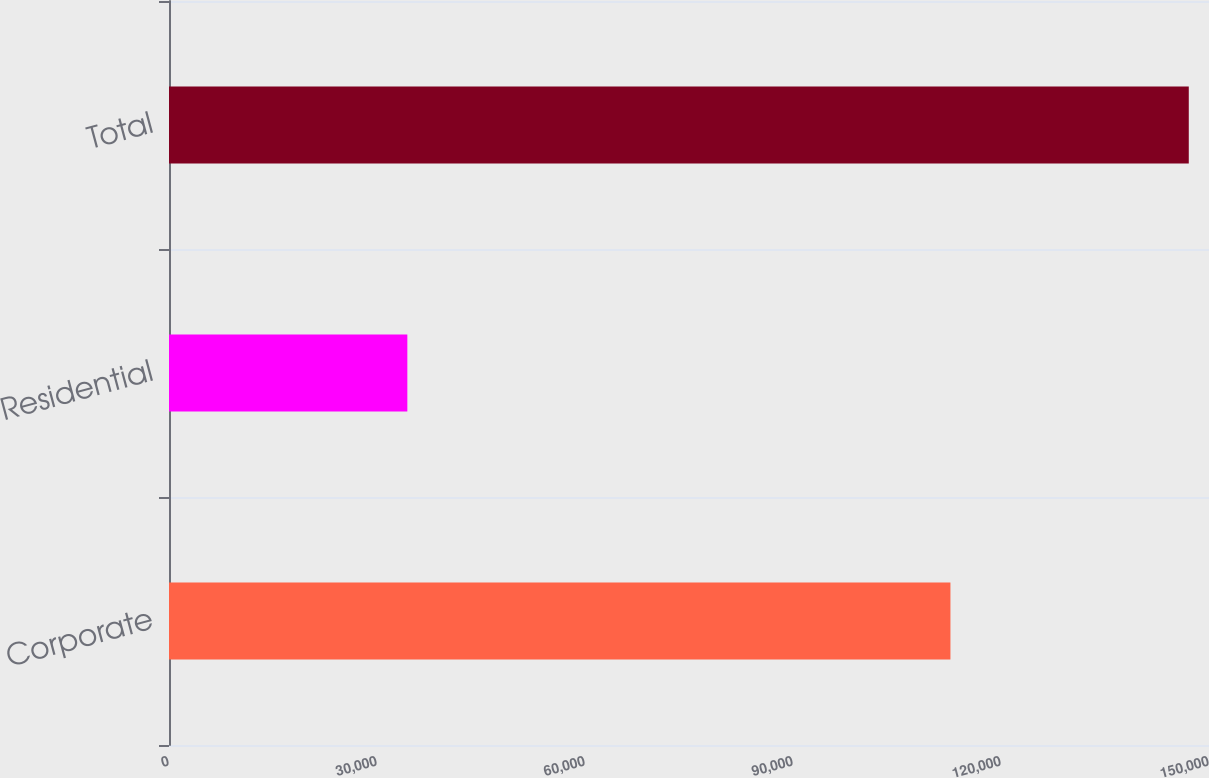Convert chart to OTSL. <chart><loc_0><loc_0><loc_500><loc_500><bar_chart><fcel>Corporate<fcel>Residential<fcel>Total<nl><fcel>112708<fcel>34376<fcel>147084<nl></chart> 